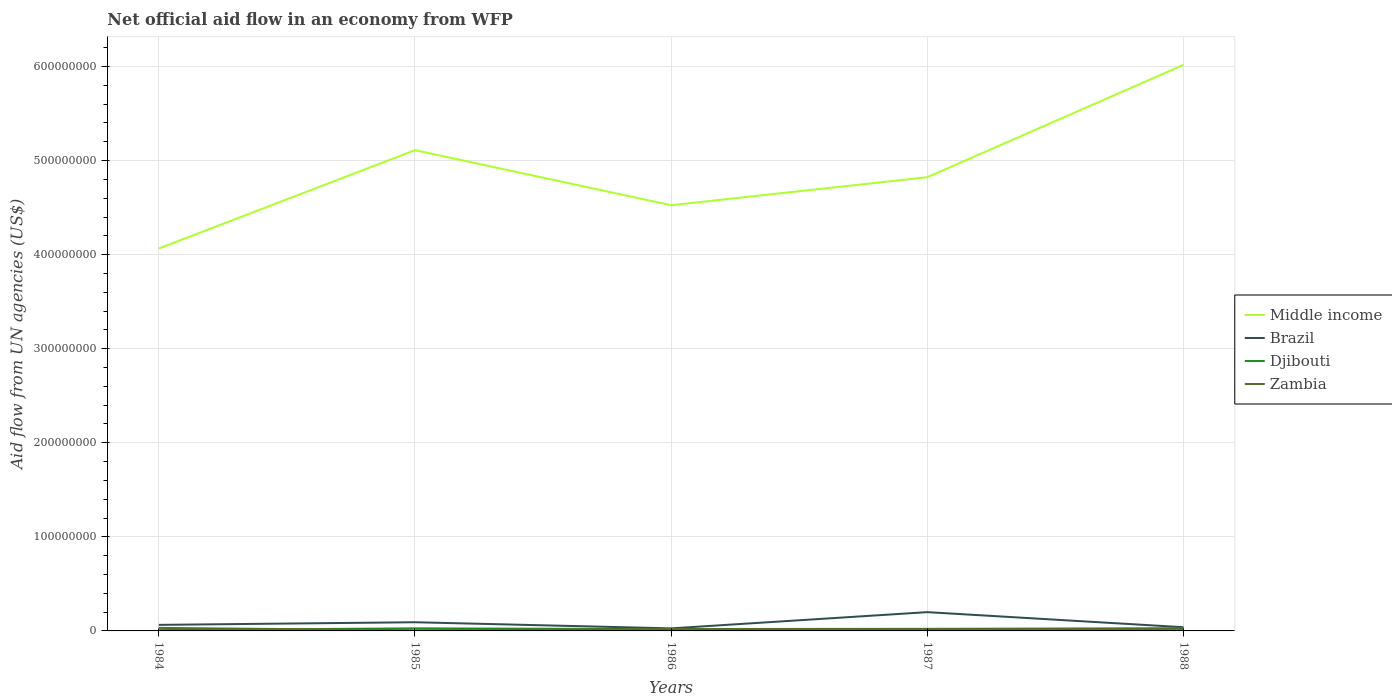Does the line corresponding to Djibouti intersect with the line corresponding to Brazil?
Your answer should be very brief. No. Across all years, what is the maximum net official aid flow in Zambia?
Provide a succinct answer. 7.20e+05. What is the total net official aid flow in Brazil in the graph?
Your response must be concise. 2.51e+06. What is the difference between the highest and the second highest net official aid flow in Brazil?
Give a very brief answer. 1.73e+07. What is the difference between the highest and the lowest net official aid flow in Brazil?
Your answer should be very brief. 2. How many lines are there?
Your answer should be compact. 4. Are the values on the major ticks of Y-axis written in scientific E-notation?
Offer a terse response. No. Does the graph contain any zero values?
Provide a short and direct response. No. Does the graph contain grids?
Your answer should be compact. Yes. How are the legend labels stacked?
Your response must be concise. Vertical. What is the title of the graph?
Provide a short and direct response. Net official aid flow in an economy from WFP. What is the label or title of the X-axis?
Offer a terse response. Years. What is the label or title of the Y-axis?
Offer a very short reply. Aid flow from UN agencies (US$). What is the Aid flow from UN agencies (US$) in Middle income in 1984?
Give a very brief answer. 4.06e+08. What is the Aid flow from UN agencies (US$) in Brazil in 1984?
Provide a succinct answer. 6.43e+06. What is the Aid flow from UN agencies (US$) in Djibouti in 1984?
Keep it short and to the point. 8.90e+05. What is the Aid flow from UN agencies (US$) in Zambia in 1984?
Provide a succinct answer. 3.22e+06. What is the Aid flow from UN agencies (US$) in Middle income in 1985?
Offer a very short reply. 5.11e+08. What is the Aid flow from UN agencies (US$) in Brazil in 1985?
Your answer should be compact. 9.24e+06. What is the Aid flow from UN agencies (US$) in Djibouti in 1985?
Offer a very short reply. 2.75e+06. What is the Aid flow from UN agencies (US$) in Zambia in 1985?
Your answer should be compact. 7.20e+05. What is the Aid flow from UN agencies (US$) in Middle income in 1986?
Offer a terse response. 4.53e+08. What is the Aid flow from UN agencies (US$) of Brazil in 1986?
Provide a short and direct response. 2.70e+06. What is the Aid flow from UN agencies (US$) of Djibouti in 1986?
Offer a terse response. 1.89e+06. What is the Aid flow from UN agencies (US$) of Zambia in 1986?
Offer a terse response. 2.02e+06. What is the Aid flow from UN agencies (US$) in Middle income in 1987?
Keep it short and to the point. 4.82e+08. What is the Aid flow from UN agencies (US$) of Brazil in 1987?
Keep it short and to the point. 2.00e+07. What is the Aid flow from UN agencies (US$) in Djibouti in 1987?
Ensure brevity in your answer.  1.39e+06. What is the Aid flow from UN agencies (US$) in Zambia in 1987?
Provide a succinct answer. 2.23e+06. What is the Aid flow from UN agencies (US$) of Middle income in 1988?
Ensure brevity in your answer.  6.02e+08. What is the Aid flow from UN agencies (US$) in Brazil in 1988?
Provide a succinct answer. 3.92e+06. What is the Aid flow from UN agencies (US$) in Djibouti in 1988?
Provide a succinct answer. 2.14e+06. What is the Aid flow from UN agencies (US$) of Zambia in 1988?
Give a very brief answer. 2.89e+06. Across all years, what is the maximum Aid flow from UN agencies (US$) of Middle income?
Offer a very short reply. 6.02e+08. Across all years, what is the maximum Aid flow from UN agencies (US$) of Brazil?
Offer a terse response. 2.00e+07. Across all years, what is the maximum Aid flow from UN agencies (US$) of Djibouti?
Give a very brief answer. 2.75e+06. Across all years, what is the maximum Aid flow from UN agencies (US$) of Zambia?
Offer a terse response. 3.22e+06. Across all years, what is the minimum Aid flow from UN agencies (US$) of Middle income?
Give a very brief answer. 4.06e+08. Across all years, what is the minimum Aid flow from UN agencies (US$) of Brazil?
Give a very brief answer. 2.70e+06. Across all years, what is the minimum Aid flow from UN agencies (US$) in Djibouti?
Offer a very short reply. 8.90e+05. Across all years, what is the minimum Aid flow from UN agencies (US$) in Zambia?
Provide a succinct answer. 7.20e+05. What is the total Aid flow from UN agencies (US$) of Middle income in the graph?
Offer a terse response. 2.45e+09. What is the total Aid flow from UN agencies (US$) in Brazil in the graph?
Provide a succinct answer. 4.22e+07. What is the total Aid flow from UN agencies (US$) of Djibouti in the graph?
Provide a short and direct response. 9.06e+06. What is the total Aid flow from UN agencies (US$) of Zambia in the graph?
Offer a very short reply. 1.11e+07. What is the difference between the Aid flow from UN agencies (US$) in Middle income in 1984 and that in 1985?
Offer a very short reply. -1.05e+08. What is the difference between the Aid flow from UN agencies (US$) in Brazil in 1984 and that in 1985?
Ensure brevity in your answer.  -2.81e+06. What is the difference between the Aid flow from UN agencies (US$) of Djibouti in 1984 and that in 1985?
Your answer should be compact. -1.86e+06. What is the difference between the Aid flow from UN agencies (US$) of Zambia in 1984 and that in 1985?
Provide a short and direct response. 2.50e+06. What is the difference between the Aid flow from UN agencies (US$) in Middle income in 1984 and that in 1986?
Your answer should be very brief. -4.60e+07. What is the difference between the Aid flow from UN agencies (US$) in Brazil in 1984 and that in 1986?
Ensure brevity in your answer.  3.73e+06. What is the difference between the Aid flow from UN agencies (US$) of Zambia in 1984 and that in 1986?
Ensure brevity in your answer.  1.20e+06. What is the difference between the Aid flow from UN agencies (US$) in Middle income in 1984 and that in 1987?
Ensure brevity in your answer.  -7.58e+07. What is the difference between the Aid flow from UN agencies (US$) of Brazil in 1984 and that in 1987?
Keep it short and to the point. -1.35e+07. What is the difference between the Aid flow from UN agencies (US$) in Djibouti in 1984 and that in 1987?
Offer a very short reply. -5.00e+05. What is the difference between the Aid flow from UN agencies (US$) in Zambia in 1984 and that in 1987?
Keep it short and to the point. 9.90e+05. What is the difference between the Aid flow from UN agencies (US$) of Middle income in 1984 and that in 1988?
Make the answer very short. -1.95e+08. What is the difference between the Aid flow from UN agencies (US$) in Brazil in 1984 and that in 1988?
Your response must be concise. 2.51e+06. What is the difference between the Aid flow from UN agencies (US$) of Djibouti in 1984 and that in 1988?
Provide a succinct answer. -1.25e+06. What is the difference between the Aid flow from UN agencies (US$) of Middle income in 1985 and that in 1986?
Make the answer very short. 5.85e+07. What is the difference between the Aid flow from UN agencies (US$) in Brazil in 1985 and that in 1986?
Offer a terse response. 6.54e+06. What is the difference between the Aid flow from UN agencies (US$) in Djibouti in 1985 and that in 1986?
Provide a succinct answer. 8.60e+05. What is the difference between the Aid flow from UN agencies (US$) in Zambia in 1985 and that in 1986?
Provide a succinct answer. -1.30e+06. What is the difference between the Aid flow from UN agencies (US$) of Middle income in 1985 and that in 1987?
Offer a very short reply. 2.87e+07. What is the difference between the Aid flow from UN agencies (US$) of Brazil in 1985 and that in 1987?
Keep it short and to the point. -1.07e+07. What is the difference between the Aid flow from UN agencies (US$) in Djibouti in 1985 and that in 1987?
Provide a succinct answer. 1.36e+06. What is the difference between the Aid flow from UN agencies (US$) in Zambia in 1985 and that in 1987?
Offer a terse response. -1.51e+06. What is the difference between the Aid flow from UN agencies (US$) of Middle income in 1985 and that in 1988?
Provide a succinct answer. -9.07e+07. What is the difference between the Aid flow from UN agencies (US$) of Brazil in 1985 and that in 1988?
Your answer should be very brief. 5.32e+06. What is the difference between the Aid flow from UN agencies (US$) of Zambia in 1985 and that in 1988?
Your answer should be very brief. -2.17e+06. What is the difference between the Aid flow from UN agencies (US$) in Middle income in 1986 and that in 1987?
Give a very brief answer. -2.98e+07. What is the difference between the Aid flow from UN agencies (US$) in Brazil in 1986 and that in 1987?
Offer a terse response. -1.73e+07. What is the difference between the Aid flow from UN agencies (US$) in Middle income in 1986 and that in 1988?
Keep it short and to the point. -1.49e+08. What is the difference between the Aid flow from UN agencies (US$) in Brazil in 1986 and that in 1988?
Provide a short and direct response. -1.22e+06. What is the difference between the Aid flow from UN agencies (US$) of Djibouti in 1986 and that in 1988?
Provide a succinct answer. -2.50e+05. What is the difference between the Aid flow from UN agencies (US$) of Zambia in 1986 and that in 1988?
Ensure brevity in your answer.  -8.70e+05. What is the difference between the Aid flow from UN agencies (US$) of Middle income in 1987 and that in 1988?
Your answer should be very brief. -1.19e+08. What is the difference between the Aid flow from UN agencies (US$) in Brazil in 1987 and that in 1988?
Your answer should be very brief. 1.60e+07. What is the difference between the Aid flow from UN agencies (US$) of Djibouti in 1987 and that in 1988?
Give a very brief answer. -7.50e+05. What is the difference between the Aid flow from UN agencies (US$) of Zambia in 1987 and that in 1988?
Your response must be concise. -6.60e+05. What is the difference between the Aid flow from UN agencies (US$) of Middle income in 1984 and the Aid flow from UN agencies (US$) of Brazil in 1985?
Your answer should be compact. 3.97e+08. What is the difference between the Aid flow from UN agencies (US$) in Middle income in 1984 and the Aid flow from UN agencies (US$) in Djibouti in 1985?
Your response must be concise. 4.04e+08. What is the difference between the Aid flow from UN agencies (US$) in Middle income in 1984 and the Aid flow from UN agencies (US$) in Zambia in 1985?
Provide a succinct answer. 4.06e+08. What is the difference between the Aid flow from UN agencies (US$) in Brazil in 1984 and the Aid flow from UN agencies (US$) in Djibouti in 1985?
Make the answer very short. 3.68e+06. What is the difference between the Aid flow from UN agencies (US$) in Brazil in 1984 and the Aid flow from UN agencies (US$) in Zambia in 1985?
Your answer should be compact. 5.71e+06. What is the difference between the Aid flow from UN agencies (US$) in Middle income in 1984 and the Aid flow from UN agencies (US$) in Brazil in 1986?
Your answer should be very brief. 4.04e+08. What is the difference between the Aid flow from UN agencies (US$) in Middle income in 1984 and the Aid flow from UN agencies (US$) in Djibouti in 1986?
Provide a short and direct response. 4.05e+08. What is the difference between the Aid flow from UN agencies (US$) of Middle income in 1984 and the Aid flow from UN agencies (US$) of Zambia in 1986?
Your response must be concise. 4.04e+08. What is the difference between the Aid flow from UN agencies (US$) in Brazil in 1984 and the Aid flow from UN agencies (US$) in Djibouti in 1986?
Offer a very short reply. 4.54e+06. What is the difference between the Aid flow from UN agencies (US$) in Brazil in 1984 and the Aid flow from UN agencies (US$) in Zambia in 1986?
Make the answer very short. 4.41e+06. What is the difference between the Aid flow from UN agencies (US$) in Djibouti in 1984 and the Aid flow from UN agencies (US$) in Zambia in 1986?
Your answer should be compact. -1.13e+06. What is the difference between the Aid flow from UN agencies (US$) of Middle income in 1984 and the Aid flow from UN agencies (US$) of Brazil in 1987?
Your answer should be compact. 3.87e+08. What is the difference between the Aid flow from UN agencies (US$) of Middle income in 1984 and the Aid flow from UN agencies (US$) of Djibouti in 1987?
Give a very brief answer. 4.05e+08. What is the difference between the Aid flow from UN agencies (US$) of Middle income in 1984 and the Aid flow from UN agencies (US$) of Zambia in 1987?
Make the answer very short. 4.04e+08. What is the difference between the Aid flow from UN agencies (US$) of Brazil in 1984 and the Aid flow from UN agencies (US$) of Djibouti in 1987?
Make the answer very short. 5.04e+06. What is the difference between the Aid flow from UN agencies (US$) in Brazil in 1984 and the Aid flow from UN agencies (US$) in Zambia in 1987?
Provide a succinct answer. 4.20e+06. What is the difference between the Aid flow from UN agencies (US$) in Djibouti in 1984 and the Aid flow from UN agencies (US$) in Zambia in 1987?
Your answer should be very brief. -1.34e+06. What is the difference between the Aid flow from UN agencies (US$) in Middle income in 1984 and the Aid flow from UN agencies (US$) in Brazil in 1988?
Offer a terse response. 4.03e+08. What is the difference between the Aid flow from UN agencies (US$) in Middle income in 1984 and the Aid flow from UN agencies (US$) in Djibouti in 1988?
Your answer should be very brief. 4.04e+08. What is the difference between the Aid flow from UN agencies (US$) in Middle income in 1984 and the Aid flow from UN agencies (US$) in Zambia in 1988?
Give a very brief answer. 4.04e+08. What is the difference between the Aid flow from UN agencies (US$) in Brazil in 1984 and the Aid flow from UN agencies (US$) in Djibouti in 1988?
Provide a short and direct response. 4.29e+06. What is the difference between the Aid flow from UN agencies (US$) of Brazil in 1984 and the Aid flow from UN agencies (US$) of Zambia in 1988?
Provide a succinct answer. 3.54e+06. What is the difference between the Aid flow from UN agencies (US$) in Middle income in 1985 and the Aid flow from UN agencies (US$) in Brazil in 1986?
Keep it short and to the point. 5.08e+08. What is the difference between the Aid flow from UN agencies (US$) in Middle income in 1985 and the Aid flow from UN agencies (US$) in Djibouti in 1986?
Make the answer very short. 5.09e+08. What is the difference between the Aid flow from UN agencies (US$) in Middle income in 1985 and the Aid flow from UN agencies (US$) in Zambia in 1986?
Keep it short and to the point. 5.09e+08. What is the difference between the Aid flow from UN agencies (US$) of Brazil in 1985 and the Aid flow from UN agencies (US$) of Djibouti in 1986?
Give a very brief answer. 7.35e+06. What is the difference between the Aid flow from UN agencies (US$) in Brazil in 1985 and the Aid flow from UN agencies (US$) in Zambia in 1986?
Make the answer very short. 7.22e+06. What is the difference between the Aid flow from UN agencies (US$) in Djibouti in 1985 and the Aid flow from UN agencies (US$) in Zambia in 1986?
Provide a succinct answer. 7.30e+05. What is the difference between the Aid flow from UN agencies (US$) of Middle income in 1985 and the Aid flow from UN agencies (US$) of Brazil in 1987?
Offer a very short reply. 4.91e+08. What is the difference between the Aid flow from UN agencies (US$) of Middle income in 1985 and the Aid flow from UN agencies (US$) of Djibouti in 1987?
Your response must be concise. 5.10e+08. What is the difference between the Aid flow from UN agencies (US$) in Middle income in 1985 and the Aid flow from UN agencies (US$) in Zambia in 1987?
Keep it short and to the point. 5.09e+08. What is the difference between the Aid flow from UN agencies (US$) in Brazil in 1985 and the Aid flow from UN agencies (US$) in Djibouti in 1987?
Your response must be concise. 7.85e+06. What is the difference between the Aid flow from UN agencies (US$) of Brazil in 1985 and the Aid flow from UN agencies (US$) of Zambia in 1987?
Provide a succinct answer. 7.01e+06. What is the difference between the Aid flow from UN agencies (US$) in Djibouti in 1985 and the Aid flow from UN agencies (US$) in Zambia in 1987?
Your answer should be compact. 5.20e+05. What is the difference between the Aid flow from UN agencies (US$) in Middle income in 1985 and the Aid flow from UN agencies (US$) in Brazil in 1988?
Keep it short and to the point. 5.07e+08. What is the difference between the Aid flow from UN agencies (US$) in Middle income in 1985 and the Aid flow from UN agencies (US$) in Djibouti in 1988?
Give a very brief answer. 5.09e+08. What is the difference between the Aid flow from UN agencies (US$) of Middle income in 1985 and the Aid flow from UN agencies (US$) of Zambia in 1988?
Your answer should be compact. 5.08e+08. What is the difference between the Aid flow from UN agencies (US$) in Brazil in 1985 and the Aid flow from UN agencies (US$) in Djibouti in 1988?
Provide a short and direct response. 7.10e+06. What is the difference between the Aid flow from UN agencies (US$) of Brazil in 1985 and the Aid flow from UN agencies (US$) of Zambia in 1988?
Offer a very short reply. 6.35e+06. What is the difference between the Aid flow from UN agencies (US$) of Djibouti in 1985 and the Aid flow from UN agencies (US$) of Zambia in 1988?
Ensure brevity in your answer.  -1.40e+05. What is the difference between the Aid flow from UN agencies (US$) of Middle income in 1986 and the Aid flow from UN agencies (US$) of Brazil in 1987?
Offer a terse response. 4.33e+08. What is the difference between the Aid flow from UN agencies (US$) in Middle income in 1986 and the Aid flow from UN agencies (US$) in Djibouti in 1987?
Ensure brevity in your answer.  4.51e+08. What is the difference between the Aid flow from UN agencies (US$) in Middle income in 1986 and the Aid flow from UN agencies (US$) in Zambia in 1987?
Keep it short and to the point. 4.50e+08. What is the difference between the Aid flow from UN agencies (US$) of Brazil in 1986 and the Aid flow from UN agencies (US$) of Djibouti in 1987?
Your answer should be compact. 1.31e+06. What is the difference between the Aid flow from UN agencies (US$) in Middle income in 1986 and the Aid flow from UN agencies (US$) in Brazil in 1988?
Your response must be concise. 4.49e+08. What is the difference between the Aid flow from UN agencies (US$) in Middle income in 1986 and the Aid flow from UN agencies (US$) in Djibouti in 1988?
Make the answer very short. 4.50e+08. What is the difference between the Aid flow from UN agencies (US$) in Middle income in 1986 and the Aid flow from UN agencies (US$) in Zambia in 1988?
Your answer should be compact. 4.50e+08. What is the difference between the Aid flow from UN agencies (US$) in Brazil in 1986 and the Aid flow from UN agencies (US$) in Djibouti in 1988?
Keep it short and to the point. 5.60e+05. What is the difference between the Aid flow from UN agencies (US$) in Brazil in 1986 and the Aid flow from UN agencies (US$) in Zambia in 1988?
Your answer should be very brief. -1.90e+05. What is the difference between the Aid flow from UN agencies (US$) of Djibouti in 1986 and the Aid flow from UN agencies (US$) of Zambia in 1988?
Provide a succinct answer. -1.00e+06. What is the difference between the Aid flow from UN agencies (US$) in Middle income in 1987 and the Aid flow from UN agencies (US$) in Brazil in 1988?
Give a very brief answer. 4.78e+08. What is the difference between the Aid flow from UN agencies (US$) of Middle income in 1987 and the Aid flow from UN agencies (US$) of Djibouti in 1988?
Offer a very short reply. 4.80e+08. What is the difference between the Aid flow from UN agencies (US$) of Middle income in 1987 and the Aid flow from UN agencies (US$) of Zambia in 1988?
Offer a terse response. 4.79e+08. What is the difference between the Aid flow from UN agencies (US$) of Brazil in 1987 and the Aid flow from UN agencies (US$) of Djibouti in 1988?
Provide a short and direct response. 1.78e+07. What is the difference between the Aid flow from UN agencies (US$) of Brazil in 1987 and the Aid flow from UN agencies (US$) of Zambia in 1988?
Ensure brevity in your answer.  1.71e+07. What is the difference between the Aid flow from UN agencies (US$) of Djibouti in 1987 and the Aid flow from UN agencies (US$) of Zambia in 1988?
Provide a succinct answer. -1.50e+06. What is the average Aid flow from UN agencies (US$) in Middle income per year?
Provide a succinct answer. 4.91e+08. What is the average Aid flow from UN agencies (US$) of Brazil per year?
Ensure brevity in your answer.  8.45e+06. What is the average Aid flow from UN agencies (US$) of Djibouti per year?
Provide a succinct answer. 1.81e+06. What is the average Aid flow from UN agencies (US$) of Zambia per year?
Your answer should be very brief. 2.22e+06. In the year 1984, what is the difference between the Aid flow from UN agencies (US$) of Middle income and Aid flow from UN agencies (US$) of Brazil?
Ensure brevity in your answer.  4.00e+08. In the year 1984, what is the difference between the Aid flow from UN agencies (US$) in Middle income and Aid flow from UN agencies (US$) in Djibouti?
Offer a terse response. 4.06e+08. In the year 1984, what is the difference between the Aid flow from UN agencies (US$) of Middle income and Aid flow from UN agencies (US$) of Zambia?
Your answer should be very brief. 4.03e+08. In the year 1984, what is the difference between the Aid flow from UN agencies (US$) of Brazil and Aid flow from UN agencies (US$) of Djibouti?
Keep it short and to the point. 5.54e+06. In the year 1984, what is the difference between the Aid flow from UN agencies (US$) in Brazil and Aid flow from UN agencies (US$) in Zambia?
Give a very brief answer. 3.21e+06. In the year 1984, what is the difference between the Aid flow from UN agencies (US$) of Djibouti and Aid flow from UN agencies (US$) of Zambia?
Your answer should be compact. -2.33e+06. In the year 1985, what is the difference between the Aid flow from UN agencies (US$) of Middle income and Aid flow from UN agencies (US$) of Brazil?
Give a very brief answer. 5.02e+08. In the year 1985, what is the difference between the Aid flow from UN agencies (US$) in Middle income and Aid flow from UN agencies (US$) in Djibouti?
Keep it short and to the point. 5.08e+08. In the year 1985, what is the difference between the Aid flow from UN agencies (US$) of Middle income and Aid flow from UN agencies (US$) of Zambia?
Your answer should be very brief. 5.10e+08. In the year 1985, what is the difference between the Aid flow from UN agencies (US$) of Brazil and Aid flow from UN agencies (US$) of Djibouti?
Offer a very short reply. 6.49e+06. In the year 1985, what is the difference between the Aid flow from UN agencies (US$) of Brazil and Aid flow from UN agencies (US$) of Zambia?
Offer a very short reply. 8.52e+06. In the year 1985, what is the difference between the Aid flow from UN agencies (US$) in Djibouti and Aid flow from UN agencies (US$) in Zambia?
Ensure brevity in your answer.  2.03e+06. In the year 1986, what is the difference between the Aid flow from UN agencies (US$) of Middle income and Aid flow from UN agencies (US$) of Brazil?
Give a very brief answer. 4.50e+08. In the year 1986, what is the difference between the Aid flow from UN agencies (US$) in Middle income and Aid flow from UN agencies (US$) in Djibouti?
Your response must be concise. 4.51e+08. In the year 1986, what is the difference between the Aid flow from UN agencies (US$) in Middle income and Aid flow from UN agencies (US$) in Zambia?
Provide a short and direct response. 4.51e+08. In the year 1986, what is the difference between the Aid flow from UN agencies (US$) of Brazil and Aid flow from UN agencies (US$) of Djibouti?
Your response must be concise. 8.10e+05. In the year 1986, what is the difference between the Aid flow from UN agencies (US$) of Brazil and Aid flow from UN agencies (US$) of Zambia?
Your answer should be compact. 6.80e+05. In the year 1987, what is the difference between the Aid flow from UN agencies (US$) in Middle income and Aid flow from UN agencies (US$) in Brazil?
Offer a very short reply. 4.62e+08. In the year 1987, what is the difference between the Aid flow from UN agencies (US$) in Middle income and Aid flow from UN agencies (US$) in Djibouti?
Your response must be concise. 4.81e+08. In the year 1987, what is the difference between the Aid flow from UN agencies (US$) of Middle income and Aid flow from UN agencies (US$) of Zambia?
Your response must be concise. 4.80e+08. In the year 1987, what is the difference between the Aid flow from UN agencies (US$) in Brazil and Aid flow from UN agencies (US$) in Djibouti?
Your answer should be very brief. 1.86e+07. In the year 1987, what is the difference between the Aid flow from UN agencies (US$) in Brazil and Aid flow from UN agencies (US$) in Zambia?
Offer a very short reply. 1.77e+07. In the year 1987, what is the difference between the Aid flow from UN agencies (US$) of Djibouti and Aid flow from UN agencies (US$) of Zambia?
Make the answer very short. -8.40e+05. In the year 1988, what is the difference between the Aid flow from UN agencies (US$) in Middle income and Aid flow from UN agencies (US$) in Brazil?
Your response must be concise. 5.98e+08. In the year 1988, what is the difference between the Aid flow from UN agencies (US$) of Middle income and Aid flow from UN agencies (US$) of Djibouti?
Give a very brief answer. 6.00e+08. In the year 1988, what is the difference between the Aid flow from UN agencies (US$) in Middle income and Aid flow from UN agencies (US$) in Zambia?
Your response must be concise. 5.99e+08. In the year 1988, what is the difference between the Aid flow from UN agencies (US$) of Brazil and Aid flow from UN agencies (US$) of Djibouti?
Give a very brief answer. 1.78e+06. In the year 1988, what is the difference between the Aid flow from UN agencies (US$) in Brazil and Aid flow from UN agencies (US$) in Zambia?
Make the answer very short. 1.03e+06. In the year 1988, what is the difference between the Aid flow from UN agencies (US$) in Djibouti and Aid flow from UN agencies (US$) in Zambia?
Offer a very short reply. -7.50e+05. What is the ratio of the Aid flow from UN agencies (US$) in Middle income in 1984 to that in 1985?
Your answer should be compact. 0.8. What is the ratio of the Aid flow from UN agencies (US$) in Brazil in 1984 to that in 1985?
Your answer should be very brief. 0.7. What is the ratio of the Aid flow from UN agencies (US$) of Djibouti in 1984 to that in 1985?
Give a very brief answer. 0.32. What is the ratio of the Aid flow from UN agencies (US$) in Zambia in 1984 to that in 1985?
Offer a terse response. 4.47. What is the ratio of the Aid flow from UN agencies (US$) in Middle income in 1984 to that in 1986?
Your answer should be compact. 0.9. What is the ratio of the Aid flow from UN agencies (US$) in Brazil in 1984 to that in 1986?
Offer a very short reply. 2.38. What is the ratio of the Aid flow from UN agencies (US$) in Djibouti in 1984 to that in 1986?
Provide a short and direct response. 0.47. What is the ratio of the Aid flow from UN agencies (US$) of Zambia in 1984 to that in 1986?
Your answer should be compact. 1.59. What is the ratio of the Aid flow from UN agencies (US$) in Middle income in 1984 to that in 1987?
Keep it short and to the point. 0.84. What is the ratio of the Aid flow from UN agencies (US$) in Brazil in 1984 to that in 1987?
Ensure brevity in your answer.  0.32. What is the ratio of the Aid flow from UN agencies (US$) in Djibouti in 1984 to that in 1987?
Offer a very short reply. 0.64. What is the ratio of the Aid flow from UN agencies (US$) in Zambia in 1984 to that in 1987?
Keep it short and to the point. 1.44. What is the ratio of the Aid flow from UN agencies (US$) of Middle income in 1984 to that in 1988?
Your answer should be compact. 0.68. What is the ratio of the Aid flow from UN agencies (US$) of Brazil in 1984 to that in 1988?
Give a very brief answer. 1.64. What is the ratio of the Aid flow from UN agencies (US$) of Djibouti in 1984 to that in 1988?
Offer a very short reply. 0.42. What is the ratio of the Aid flow from UN agencies (US$) of Zambia in 1984 to that in 1988?
Provide a short and direct response. 1.11. What is the ratio of the Aid flow from UN agencies (US$) in Middle income in 1985 to that in 1986?
Your answer should be compact. 1.13. What is the ratio of the Aid flow from UN agencies (US$) of Brazil in 1985 to that in 1986?
Your answer should be very brief. 3.42. What is the ratio of the Aid flow from UN agencies (US$) in Djibouti in 1985 to that in 1986?
Offer a terse response. 1.46. What is the ratio of the Aid flow from UN agencies (US$) in Zambia in 1985 to that in 1986?
Ensure brevity in your answer.  0.36. What is the ratio of the Aid flow from UN agencies (US$) of Middle income in 1985 to that in 1987?
Offer a terse response. 1.06. What is the ratio of the Aid flow from UN agencies (US$) in Brazil in 1985 to that in 1987?
Your answer should be very brief. 0.46. What is the ratio of the Aid flow from UN agencies (US$) in Djibouti in 1985 to that in 1987?
Your answer should be very brief. 1.98. What is the ratio of the Aid flow from UN agencies (US$) of Zambia in 1985 to that in 1987?
Provide a succinct answer. 0.32. What is the ratio of the Aid flow from UN agencies (US$) of Middle income in 1985 to that in 1988?
Make the answer very short. 0.85. What is the ratio of the Aid flow from UN agencies (US$) of Brazil in 1985 to that in 1988?
Provide a succinct answer. 2.36. What is the ratio of the Aid flow from UN agencies (US$) in Djibouti in 1985 to that in 1988?
Give a very brief answer. 1.28. What is the ratio of the Aid flow from UN agencies (US$) in Zambia in 1985 to that in 1988?
Your response must be concise. 0.25. What is the ratio of the Aid flow from UN agencies (US$) in Middle income in 1986 to that in 1987?
Keep it short and to the point. 0.94. What is the ratio of the Aid flow from UN agencies (US$) of Brazil in 1986 to that in 1987?
Provide a short and direct response. 0.14. What is the ratio of the Aid flow from UN agencies (US$) of Djibouti in 1986 to that in 1987?
Your answer should be compact. 1.36. What is the ratio of the Aid flow from UN agencies (US$) in Zambia in 1986 to that in 1987?
Provide a short and direct response. 0.91. What is the ratio of the Aid flow from UN agencies (US$) of Middle income in 1986 to that in 1988?
Make the answer very short. 0.75. What is the ratio of the Aid flow from UN agencies (US$) of Brazil in 1986 to that in 1988?
Make the answer very short. 0.69. What is the ratio of the Aid flow from UN agencies (US$) in Djibouti in 1986 to that in 1988?
Make the answer very short. 0.88. What is the ratio of the Aid flow from UN agencies (US$) in Zambia in 1986 to that in 1988?
Offer a terse response. 0.7. What is the ratio of the Aid flow from UN agencies (US$) in Middle income in 1987 to that in 1988?
Provide a short and direct response. 0.8. What is the ratio of the Aid flow from UN agencies (US$) in Brazil in 1987 to that in 1988?
Your answer should be compact. 5.09. What is the ratio of the Aid flow from UN agencies (US$) in Djibouti in 1987 to that in 1988?
Offer a very short reply. 0.65. What is the ratio of the Aid flow from UN agencies (US$) in Zambia in 1987 to that in 1988?
Provide a succinct answer. 0.77. What is the difference between the highest and the second highest Aid flow from UN agencies (US$) of Middle income?
Provide a short and direct response. 9.07e+07. What is the difference between the highest and the second highest Aid flow from UN agencies (US$) in Brazil?
Make the answer very short. 1.07e+07. What is the difference between the highest and the second highest Aid flow from UN agencies (US$) in Zambia?
Provide a short and direct response. 3.30e+05. What is the difference between the highest and the lowest Aid flow from UN agencies (US$) in Middle income?
Your answer should be compact. 1.95e+08. What is the difference between the highest and the lowest Aid flow from UN agencies (US$) of Brazil?
Make the answer very short. 1.73e+07. What is the difference between the highest and the lowest Aid flow from UN agencies (US$) of Djibouti?
Your response must be concise. 1.86e+06. What is the difference between the highest and the lowest Aid flow from UN agencies (US$) in Zambia?
Offer a terse response. 2.50e+06. 